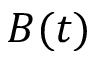<formula> <loc_0><loc_0><loc_500><loc_500>B ( t )</formula> 